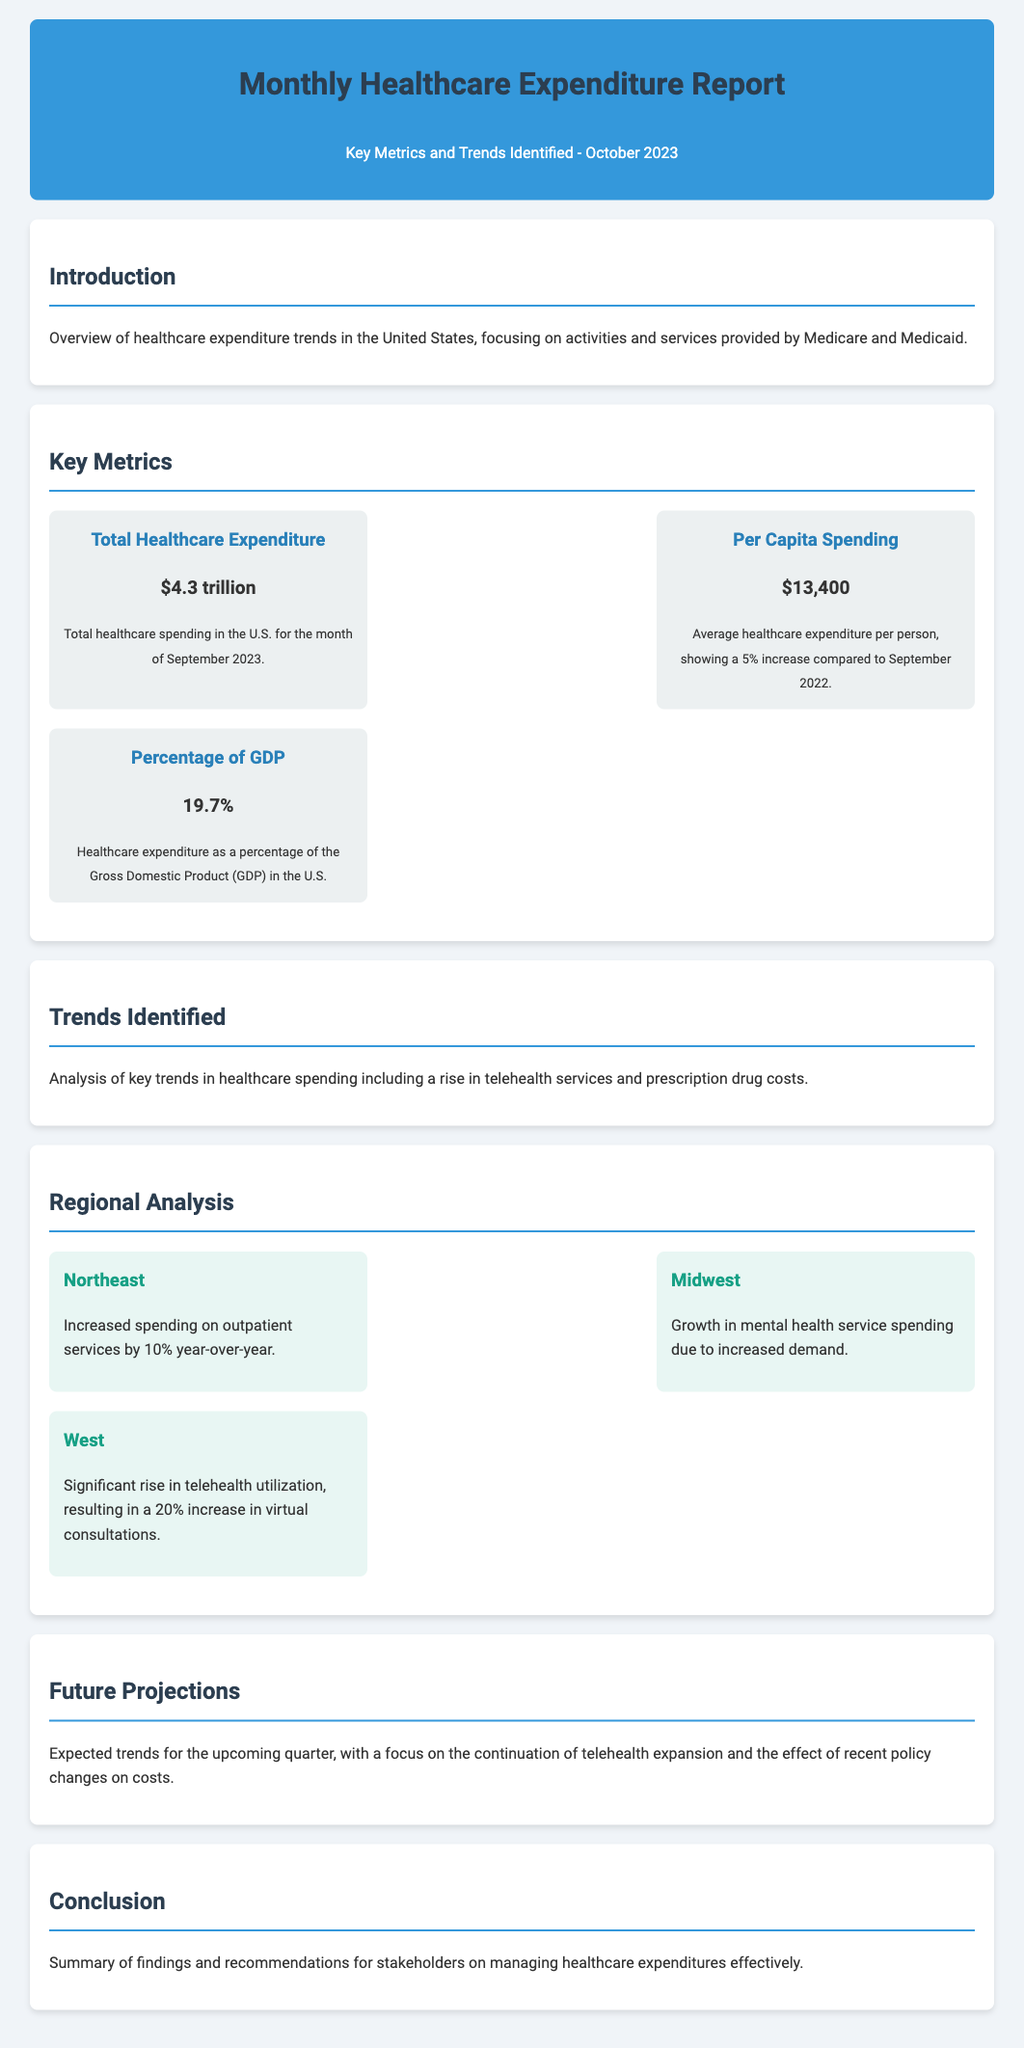What is the total healthcare expenditure? The total healthcare expenditure is provided in the document as the total spending in the U.S. for September 2023, which is $4.3 trillion.
Answer: $4.3 trillion What is the per capita spending? The per capita spending is noted in the report as the average healthcare expenditure per person, which shows a 5% increase from the previous year.
Answer: $13,400 What percentage of GDP does healthcare expenditure represent? The specific percentage of GDP that healthcare expenditure constitutes is clearly stated in the report.
Answer: 19.7% Which region saw a 10% increase in outpatient services spending? The document identifies the Northeast region as having increased spending on outpatient services by 10% year-over-year.
Answer: Northeast What type of service saw a significant rise in the West? The report highlights an increase in a specific type of service in the West, namely virtual consultations.
Answer: Telehealth What trend has been identified regarding prescription drug costs? The analysis section of the document discusses a general trend related to prescription drug costs without providing specific figures.
Answer: Rise What has been the impact on mental health service spending in the Midwest? The document notes that there has been growth in spending specifically related to mental health services in the Midwest due to demand.
Answer: Increased What is the document's main focus in the future projections? The future projections section emphasizes an upcoming trend that is closely associated with healthcare services.
Answer: Telehealth expansion What does the conclusion suggest for stakeholders? The conclusion section provides recommendations aimed at a certain action concerning healthcare expenditures.
Answer: Managing expenditures 